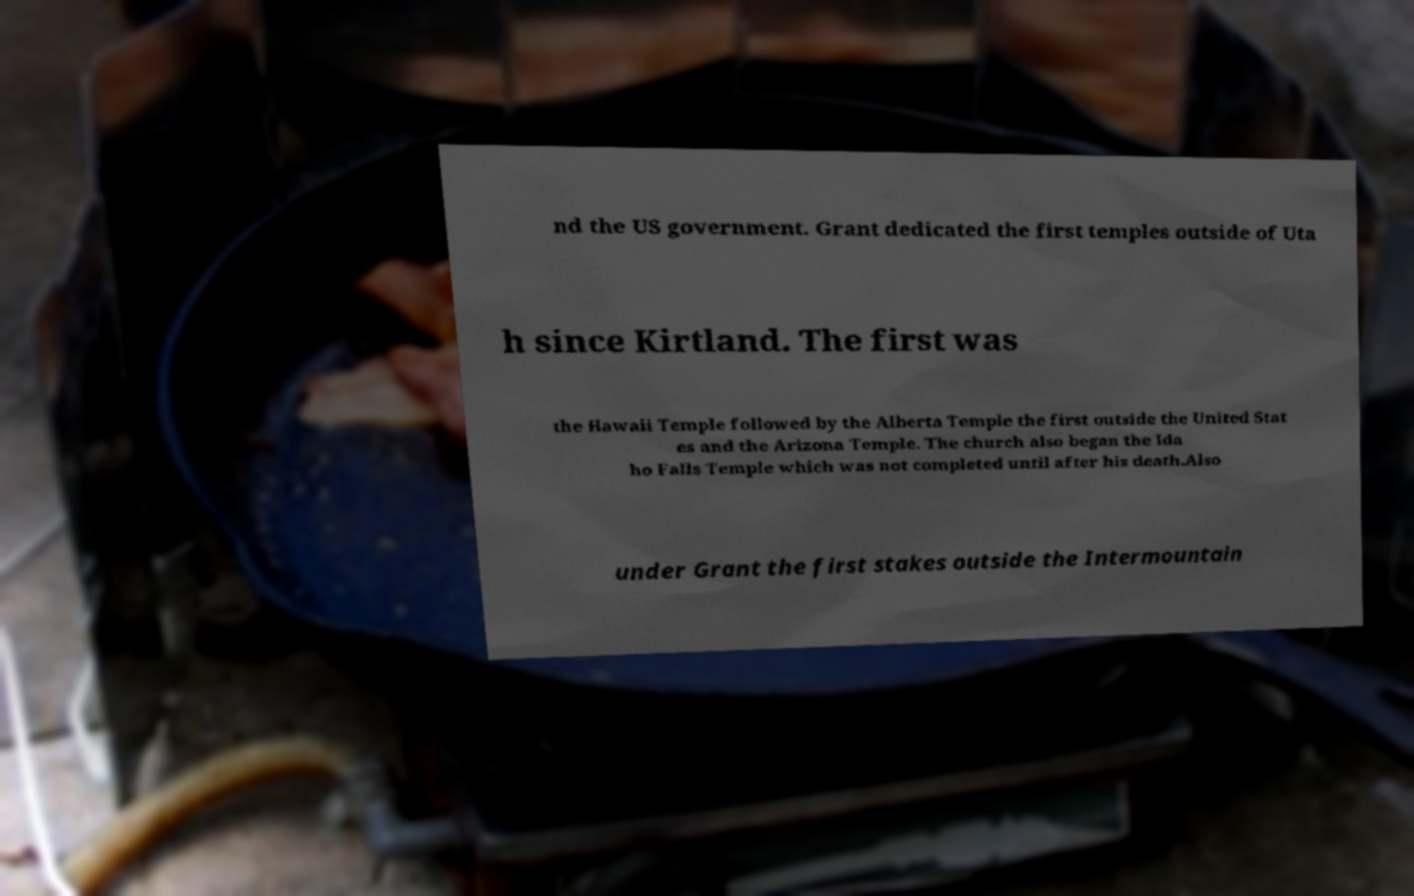Please identify and transcribe the text found in this image. nd the US government. Grant dedicated the first temples outside of Uta h since Kirtland. The first was the Hawaii Temple followed by the Alberta Temple the first outside the United Stat es and the Arizona Temple. The church also began the Ida ho Falls Temple which was not completed until after his death.Also under Grant the first stakes outside the Intermountain 